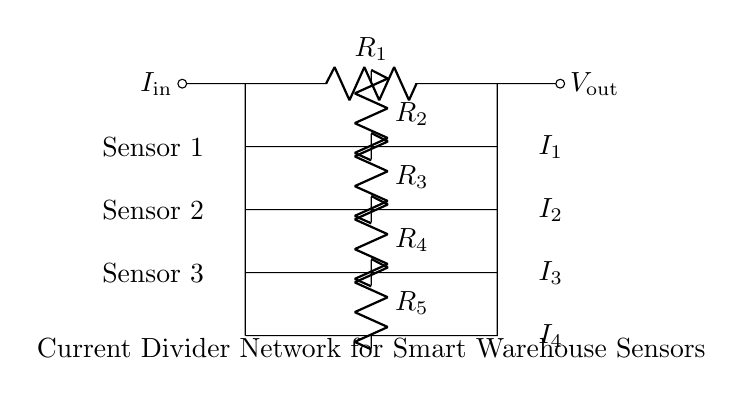What does the symbol R represent in the circuit? R stands for resistor, which is a component that impedes the flow of current in the circuit. It is used to secure specific current levels for the sensors by forming a voltage drop across them.
Answer: Resistor What is the total number of sensors in the circuit? The circuit diagram shows three sensors connected at different levels, each corresponding to a resistor in the current divider network.
Answer: Three Which resistor is connected to Sensor 1? Sensor 1 is connected to the resistor labeled R2, which is positioned directly below it in the current divider network.
Answer: R2 What type of circuit is represented by the diagram? The diagram represents a current divider circuit, which is specifically designed to distribute the current in different paths for monitoring associated output for sensors.
Answer: Current divider What happens to the current supplied to R1? The current supplied to R1 is divided among the resistors R2, R3, and R4, creating distinct currents I1, I2, and I3 for each output linked with the respective sensors.
Answer: It divides How can the current for each sensor be calculated? The current for each sensor can be calculated using the formula for a current divider, which states that the current through each branch is inversely proportional to the resistance of that branch: I_n = I_total * (R_total / R_n).
Answer: By using the current divider formula What does the current I1 represent in this circuit? I1 represents the current flowing through resistor R2 and thus through Sensor 1, indicating the specific current being monitored for that sensor.
Answer: Current for Sensor 1 